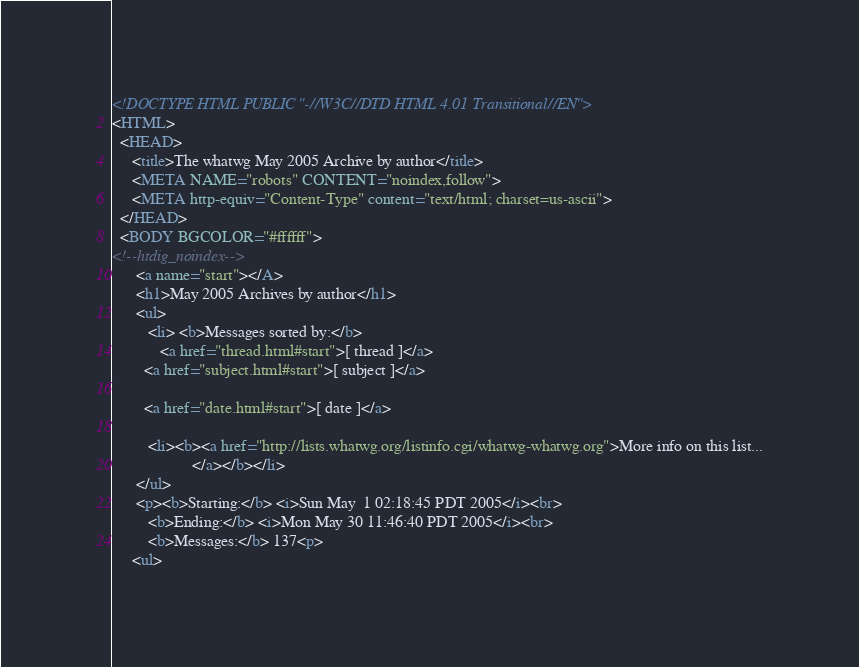Convert code to text. <code><loc_0><loc_0><loc_500><loc_500><_HTML_><!DOCTYPE HTML PUBLIC "-//W3C//DTD HTML 4.01 Transitional//EN">
<HTML>
  <HEAD>
     <title>The whatwg May 2005 Archive by author</title>
     <META NAME="robots" CONTENT="noindex,follow">
     <META http-equiv="Content-Type" content="text/html; charset=us-ascii">
  </HEAD>
  <BODY BGCOLOR="#ffffff">
<!--htdig_noindex-->
	  <a name="start"></A>
      <h1>May 2005 Archives by author</h1>
      <ul>
         <li> <b>Messages sorted by:</b>
	        <a href="thread.html#start">[ thread ]</a>
		<a href="subject.html#start">[ subject ]</a>
		
		<a href="date.html#start">[ date ]</a>

	     <li><b><a href="http://lists.whatwg.org/listinfo.cgi/whatwg-whatwg.org">More info on this list...
                    </a></b></li>
      </ul>
      <p><b>Starting:</b> <i>Sun May  1 02:18:45 PDT 2005</i><br>
         <b>Ending:</b> <i>Mon May 30 11:46:40 PDT 2005</i><br>
         <b>Messages:</b> 137<p>
     <ul></code> 